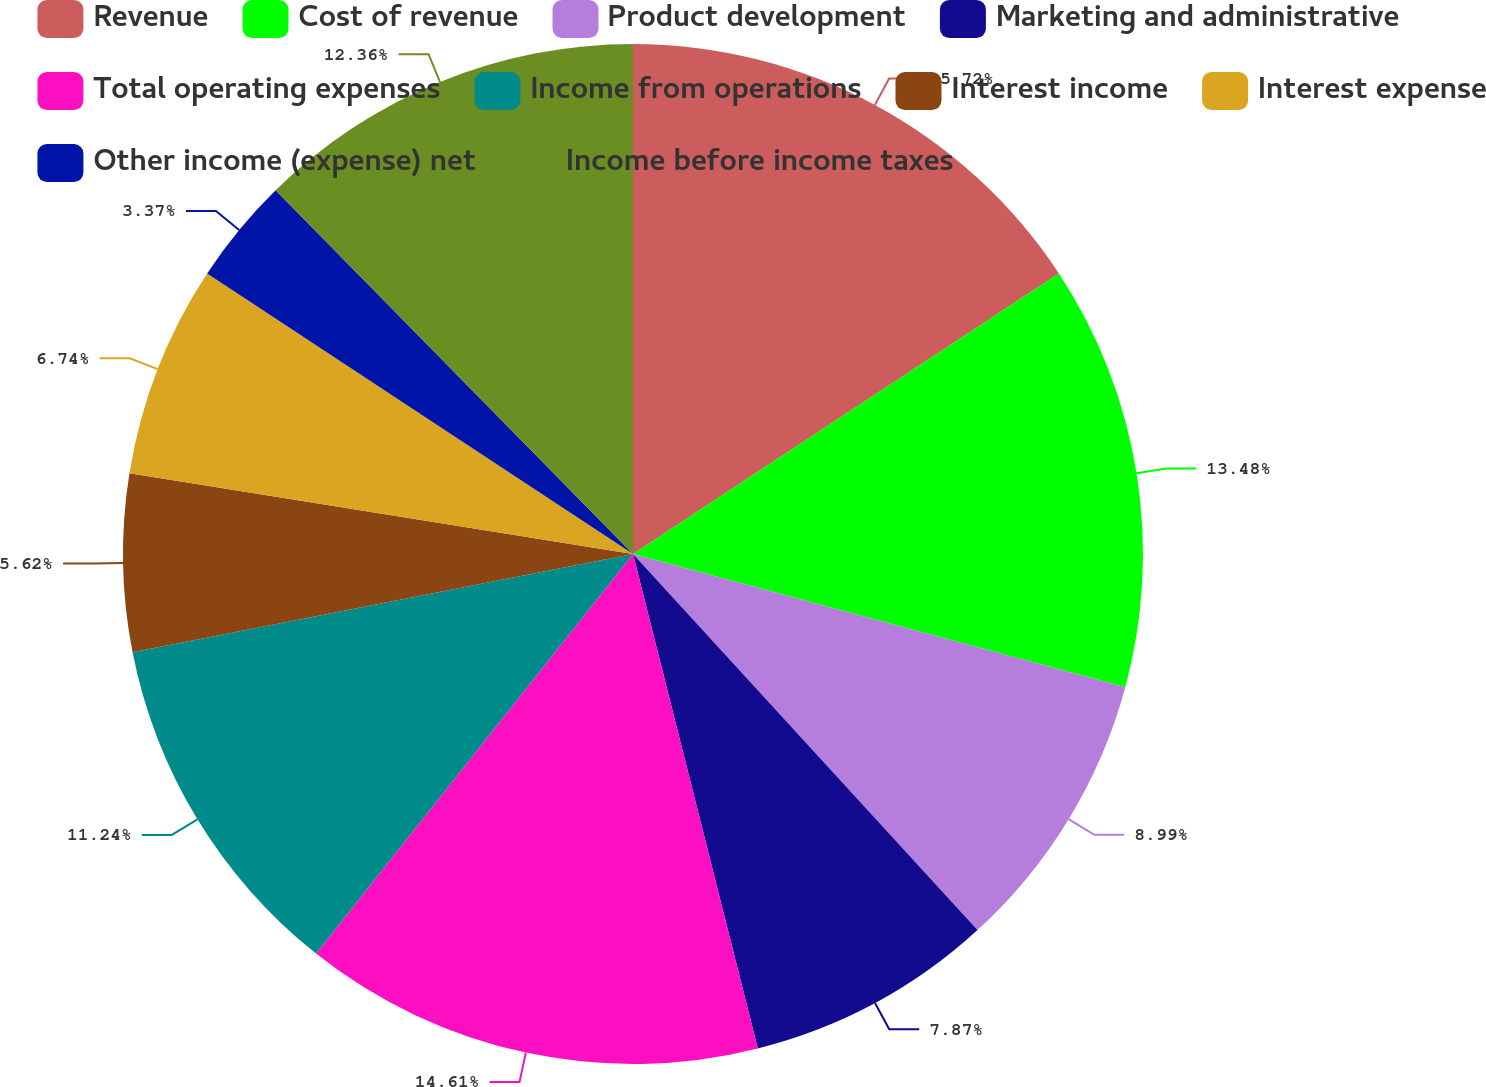Convert chart to OTSL. <chart><loc_0><loc_0><loc_500><loc_500><pie_chart><fcel>Revenue<fcel>Cost of revenue<fcel>Product development<fcel>Marketing and administrative<fcel>Total operating expenses<fcel>Income from operations<fcel>Interest income<fcel>Interest expense<fcel>Other income (expense) net<fcel>Income before income taxes<nl><fcel>15.73%<fcel>13.48%<fcel>8.99%<fcel>7.87%<fcel>14.61%<fcel>11.24%<fcel>5.62%<fcel>6.74%<fcel>3.37%<fcel>12.36%<nl></chart> 